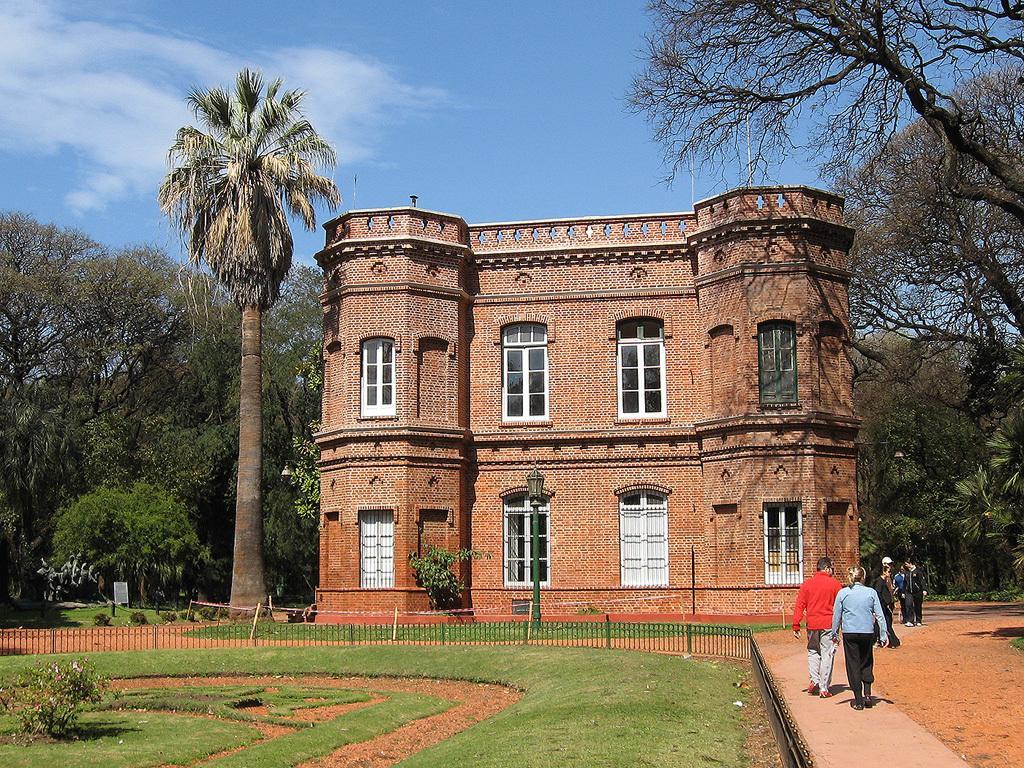Describe this image in one or two sentences. In this image there is the sky towards the top of the image, there are clouds in the sky, there is a building, there are windows, there is a pole, there is a street light, there are a group of persons walking, there are trees towards the right of the image, there are trees towards the left of the image, there is a fence towards the left of the image, there is a fence towards the bottom of the image, there is grass towards the bottom of the image, there is a plant towards the left of the image. 